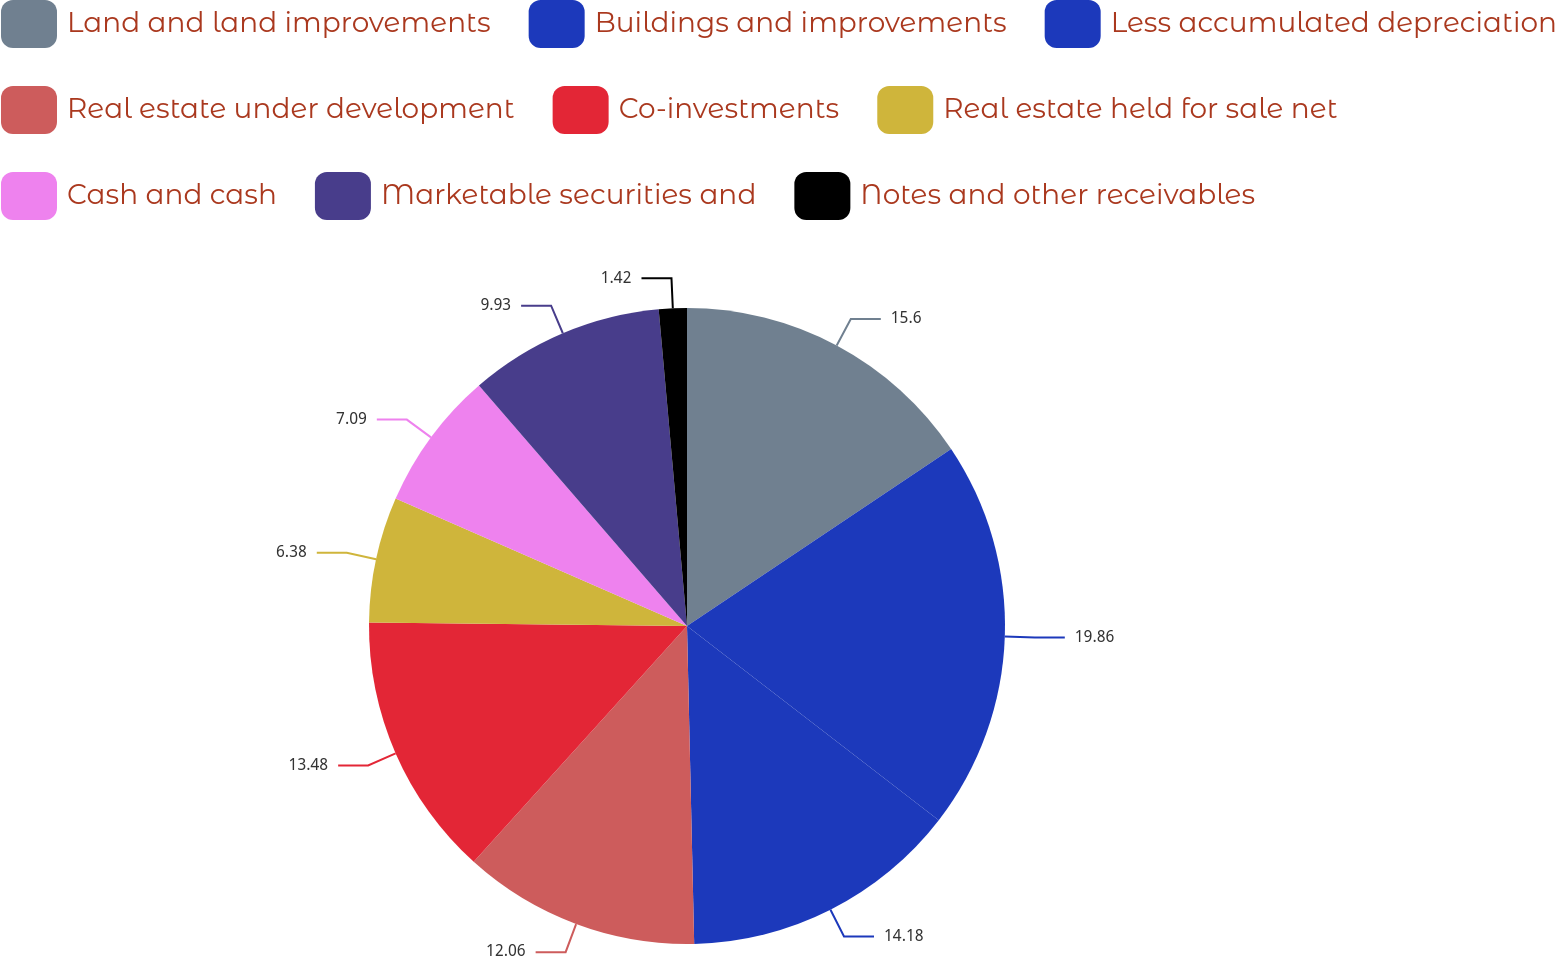Convert chart to OTSL. <chart><loc_0><loc_0><loc_500><loc_500><pie_chart><fcel>Land and land improvements<fcel>Buildings and improvements<fcel>Less accumulated depreciation<fcel>Real estate under development<fcel>Co-investments<fcel>Real estate held for sale net<fcel>Cash and cash<fcel>Marketable securities and<fcel>Notes and other receivables<nl><fcel>15.6%<fcel>19.86%<fcel>14.18%<fcel>12.06%<fcel>13.48%<fcel>6.38%<fcel>7.09%<fcel>9.93%<fcel>1.42%<nl></chart> 